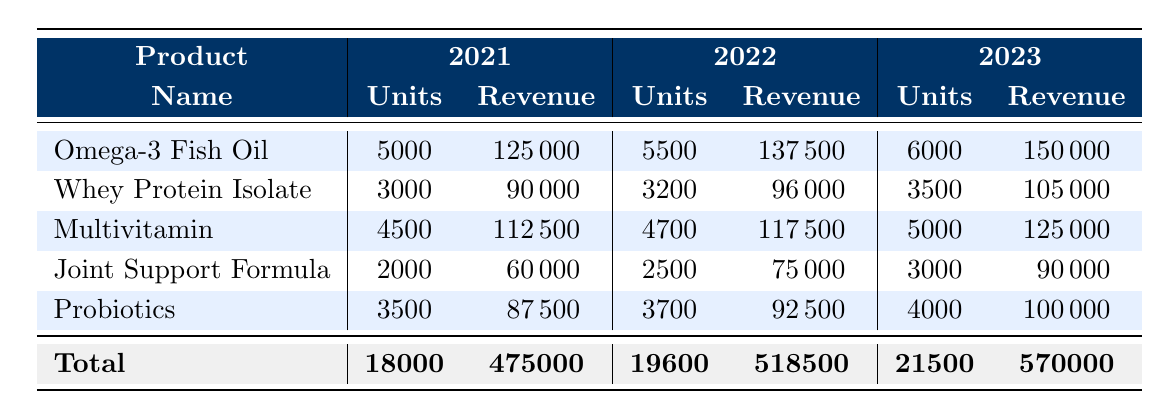What was the total revenue from health supplement sales in 2021? The total revenue from health supplement sales in 2021 is specifically listed in the table, which states the total revenue for that year as 475,000.
Answer: 475000 Which product had the highest revenue in 2023? To find the product with the highest revenue in 2023, we look across all products listed in that year. The revenues for the products in 2023 are: Omega-3 Fish Oil 150,000, Whey Protein Isolate 105,000, Multivitamin 125,000, Joint Support Formula 90,000, and Probiotics 100,000. The highest value is for Omega-3 Fish Oil at 150,000.
Answer: Omega-3 Fish Oil What is the total revenue from Multivitamin sales over the three years? We add the revenue from Multivitamin sales for each year. In 2021, it was 112,500; in 2022, it was 117,500; and in 2023, it was 125,000. So, the total is 112,500 + 117,500 + 125,000 = 355,000.
Answer: 355000 Did the sales of Whey Protein Isolate increase every year? We check the units sold for Whey Protein Isolate each year. In 2021, 3,000 units were sold, in 2022, 3,200 units, and in 2023, 3,500 units. The units sold did increase each year.
Answer: Yes What is the average revenue from sales of Probiotics over the three years? To calculate the average revenue from Probiotics, we first sum the revenues from all three years: 87,500 (2021) + 92,500 (2022) + 100,000 (2023) = 280,000. Then divide by the number of years, which is 3: 280,000 / 3 = 93,333.33.
Answer: 93333.33 Which product saw the smallest increase in revenue from 2022 to 2023? To determine the smallest increase, we calculate the difference in revenue for each product from 2022 to 2023: Omega-3 Fish Oil increased by 12,500, Whey Protein Isolate by 9,000, Multivitamin by 7,500, Joint Support Formula by 15,000, and Probiotics by 7,500. The smallest increases are 7,500 for both Multivitamin and Probiotics.
Answer: Multivitamin and Probiotics What was the total number of units sold for all products in the year 2022? We need to sum the units sold for each product in 2022: Omega-3 Fish Oil 5,500, Whey Protein Isolate 3,200, Multivitamin 4,700, Joint Support Formula 2,500, and Probiotics 3,700. Total = 5,500 + 3,200 + 4,700 + 2,500 + 3,700 = 19,600.
Answer: 19600 Was the total revenue from health supplement sales higher in 2023 compared to 2021? We compare the total revenues for both years: 2023 total revenue is 570,000, while 2021 total revenue is 475,000. Since 570,000 is greater than 475,000, it confirms that 2023 had higher revenue.
Answer: Yes What was the percentage increase in revenue from 2021 to 2022? The revenue for 2021 is 475,000 and for 2022 is 518,500. The increase is 518,500 - 475,000 = 43,500. To find the percentage increase: (43,500 / 475,000) * 100 = 9.16%.
Answer: 9.16% 